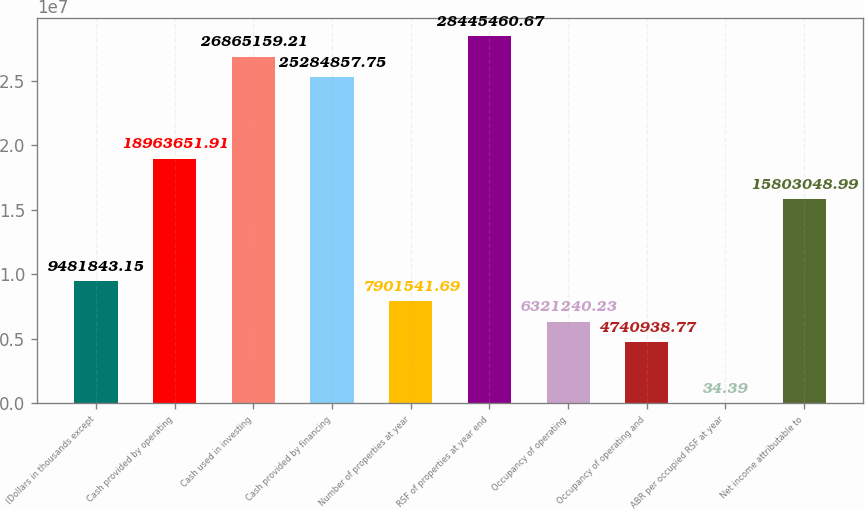Convert chart to OTSL. <chart><loc_0><loc_0><loc_500><loc_500><bar_chart><fcel>(Dollars in thousands except<fcel>Cash provided by operating<fcel>Cash used in investing<fcel>Cash provided by financing<fcel>Number of properties at year<fcel>RSF of properties at year end<fcel>Occupancy of operating<fcel>Occupancy of operating and<fcel>ABR per occupied RSF at year<fcel>Net income attributable to<nl><fcel>9.48184e+06<fcel>1.89637e+07<fcel>2.68652e+07<fcel>2.52849e+07<fcel>7.90154e+06<fcel>2.84455e+07<fcel>6.32124e+06<fcel>4.74094e+06<fcel>34.39<fcel>1.5803e+07<nl></chart> 